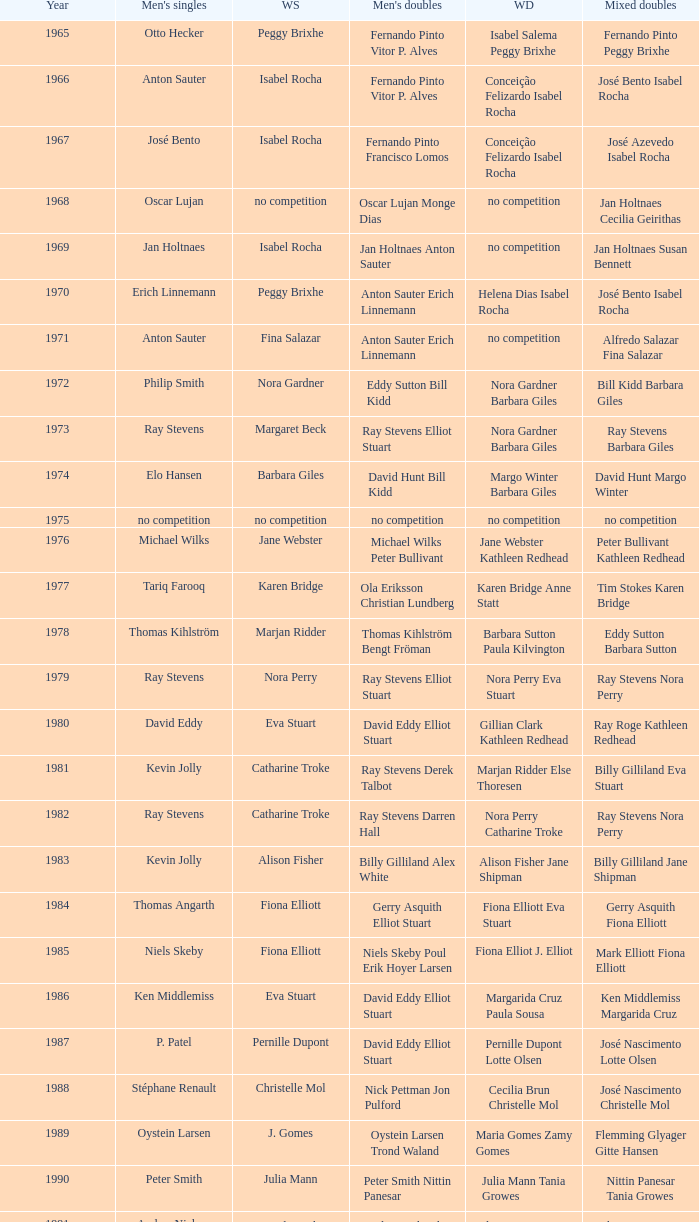Which women's doubles happened after 1987 and a women's single of astrid van der knaap? Elena Denisova Marina Yakusheva. 